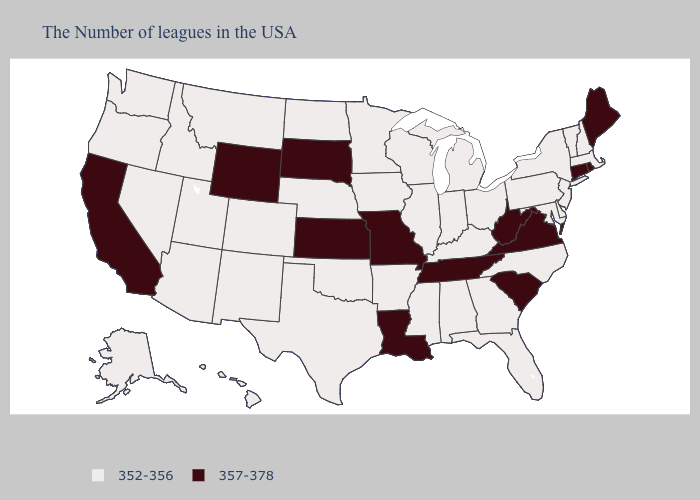What is the value of Wyoming?
Keep it brief. 357-378. Name the states that have a value in the range 352-356?
Be succinct. Massachusetts, New Hampshire, Vermont, New York, New Jersey, Delaware, Maryland, Pennsylvania, North Carolina, Ohio, Florida, Georgia, Michigan, Kentucky, Indiana, Alabama, Wisconsin, Illinois, Mississippi, Arkansas, Minnesota, Iowa, Nebraska, Oklahoma, Texas, North Dakota, Colorado, New Mexico, Utah, Montana, Arizona, Idaho, Nevada, Washington, Oregon, Alaska, Hawaii. Does the first symbol in the legend represent the smallest category?
Write a very short answer. Yes. Which states have the highest value in the USA?
Short answer required. Maine, Rhode Island, Connecticut, Virginia, South Carolina, West Virginia, Tennessee, Louisiana, Missouri, Kansas, South Dakota, Wyoming, California. What is the highest value in the USA?
Give a very brief answer. 357-378. What is the value of Utah?
Concise answer only. 352-356. Does California have the lowest value in the USA?
Quick response, please. No. Does the first symbol in the legend represent the smallest category?
Answer briefly. Yes. Does the first symbol in the legend represent the smallest category?
Give a very brief answer. Yes. Name the states that have a value in the range 352-356?
Be succinct. Massachusetts, New Hampshire, Vermont, New York, New Jersey, Delaware, Maryland, Pennsylvania, North Carolina, Ohio, Florida, Georgia, Michigan, Kentucky, Indiana, Alabama, Wisconsin, Illinois, Mississippi, Arkansas, Minnesota, Iowa, Nebraska, Oklahoma, Texas, North Dakota, Colorado, New Mexico, Utah, Montana, Arizona, Idaho, Nevada, Washington, Oregon, Alaska, Hawaii. Among the states that border Wyoming , which have the highest value?
Give a very brief answer. South Dakota. What is the value of Michigan?
Quick response, please. 352-356. Name the states that have a value in the range 352-356?
Give a very brief answer. Massachusetts, New Hampshire, Vermont, New York, New Jersey, Delaware, Maryland, Pennsylvania, North Carolina, Ohio, Florida, Georgia, Michigan, Kentucky, Indiana, Alabama, Wisconsin, Illinois, Mississippi, Arkansas, Minnesota, Iowa, Nebraska, Oklahoma, Texas, North Dakota, Colorado, New Mexico, Utah, Montana, Arizona, Idaho, Nevada, Washington, Oregon, Alaska, Hawaii. Which states hav the highest value in the Northeast?
Be succinct. Maine, Rhode Island, Connecticut. Which states have the lowest value in the USA?
Give a very brief answer. Massachusetts, New Hampshire, Vermont, New York, New Jersey, Delaware, Maryland, Pennsylvania, North Carolina, Ohio, Florida, Georgia, Michigan, Kentucky, Indiana, Alabama, Wisconsin, Illinois, Mississippi, Arkansas, Minnesota, Iowa, Nebraska, Oklahoma, Texas, North Dakota, Colorado, New Mexico, Utah, Montana, Arizona, Idaho, Nevada, Washington, Oregon, Alaska, Hawaii. 